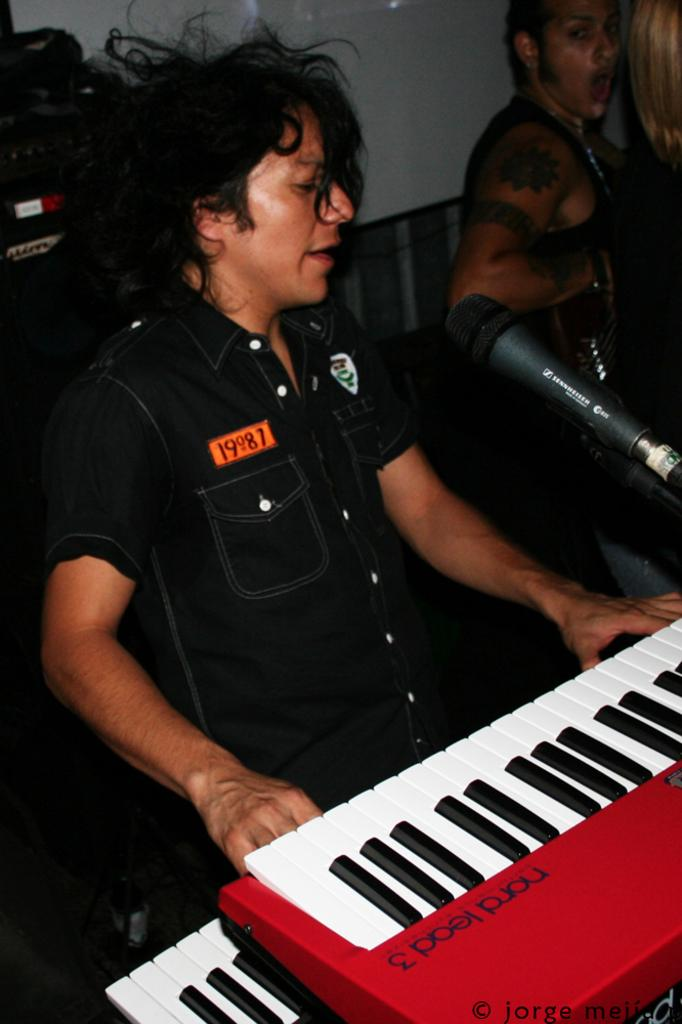What is the person in the image doing? The person is sitting on a chair, playing a piano, and singing on a microphone. Can you describe the activity the person is engaged in? The person is performing a musical act, playing the piano and singing into a microphone. Is there anyone else visible in the image? Yes, there is another person visible in the top right side of the image. What type of amusement can be seen in the image? There is no amusement park or ride present in the image; it features a person playing a piano and singing. What is the person using to store their pens and pencils in the image? There is no desk or can visible in the image for storing pens and pencils. 